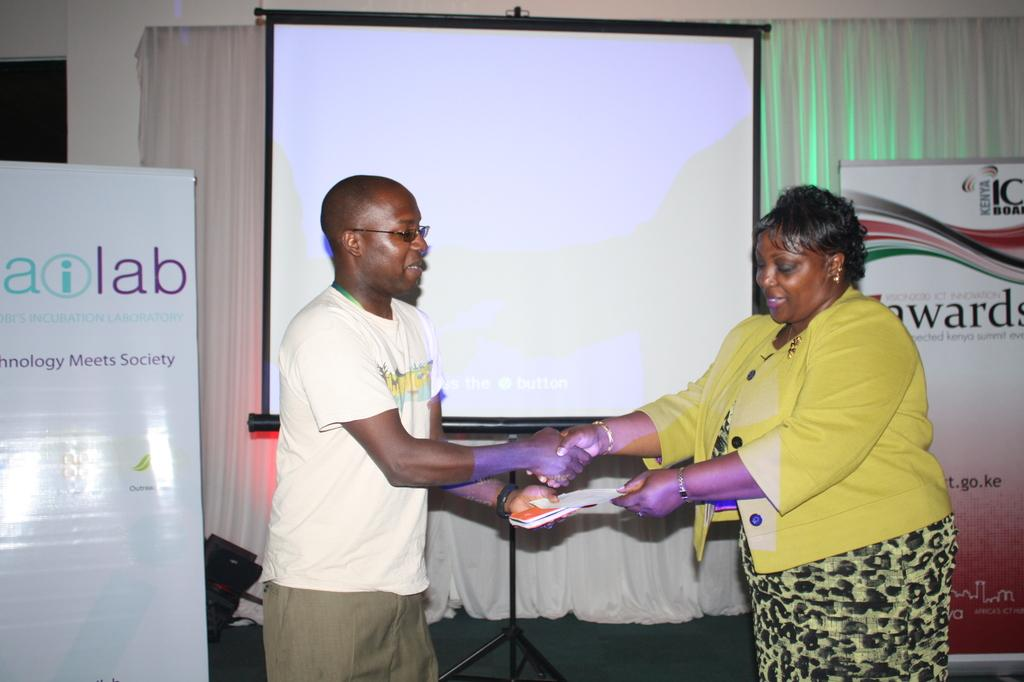How many people are in the image? There are two people in the image, a man and a woman. What are the expressions on their faces? Both the man and the woman are smiling in the image. What are they holding in their hands? They are holding a paper in their hands. What can be seen in the background of the image? There are banners, a board, a curtain, and a wall in the background of the image. What type of vase is on the table in the image? There is no vase present in the image. What is the reason behind the man and woman's smiles in the image? The image does not provide any information about the reason behind their smiles. 